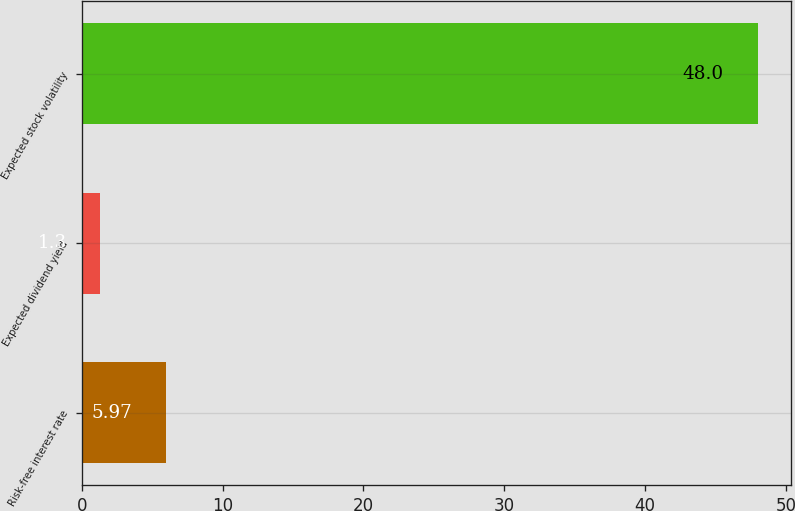Convert chart. <chart><loc_0><loc_0><loc_500><loc_500><bar_chart><fcel>Risk-free interest rate<fcel>Expected dividend yield<fcel>Expected stock volatility<nl><fcel>5.97<fcel>1.3<fcel>48<nl></chart> 